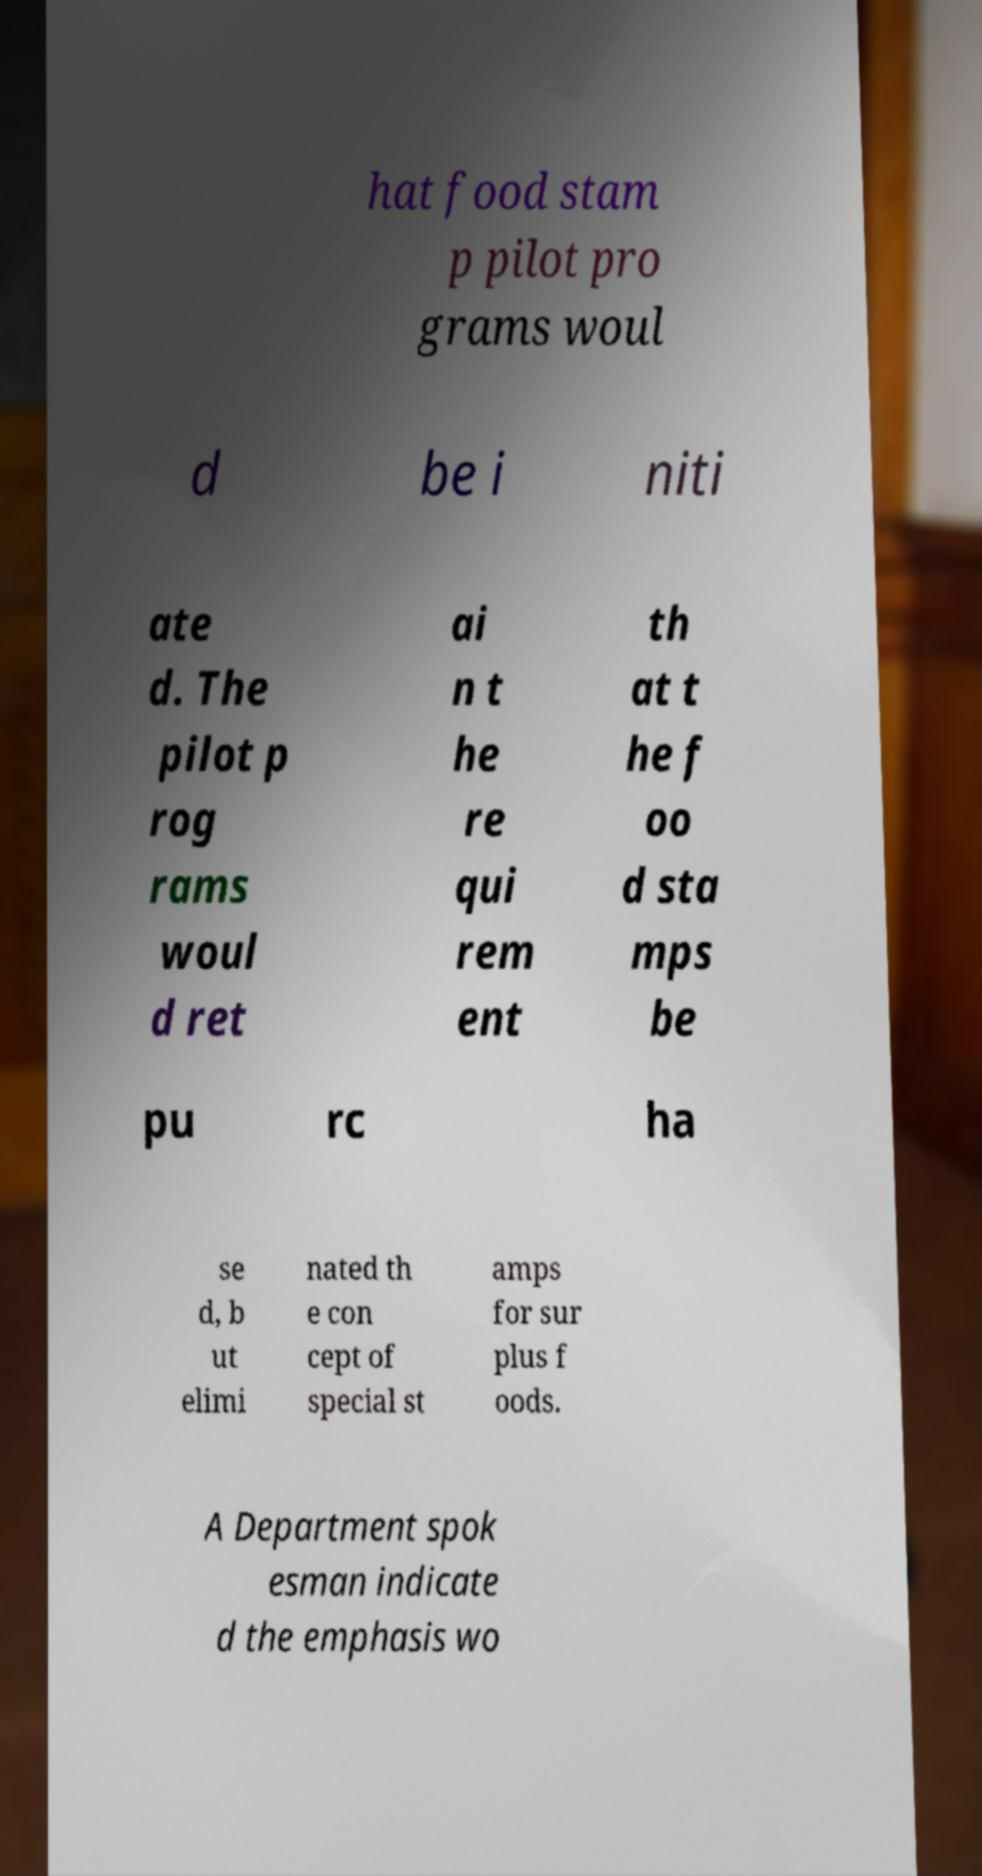Could you assist in decoding the text presented in this image and type it out clearly? hat food stam p pilot pro grams woul d be i niti ate d. The pilot p rog rams woul d ret ai n t he re qui rem ent th at t he f oo d sta mps be pu rc ha se d, b ut elimi nated th e con cept of special st amps for sur plus f oods. A Department spok esman indicate d the emphasis wo 